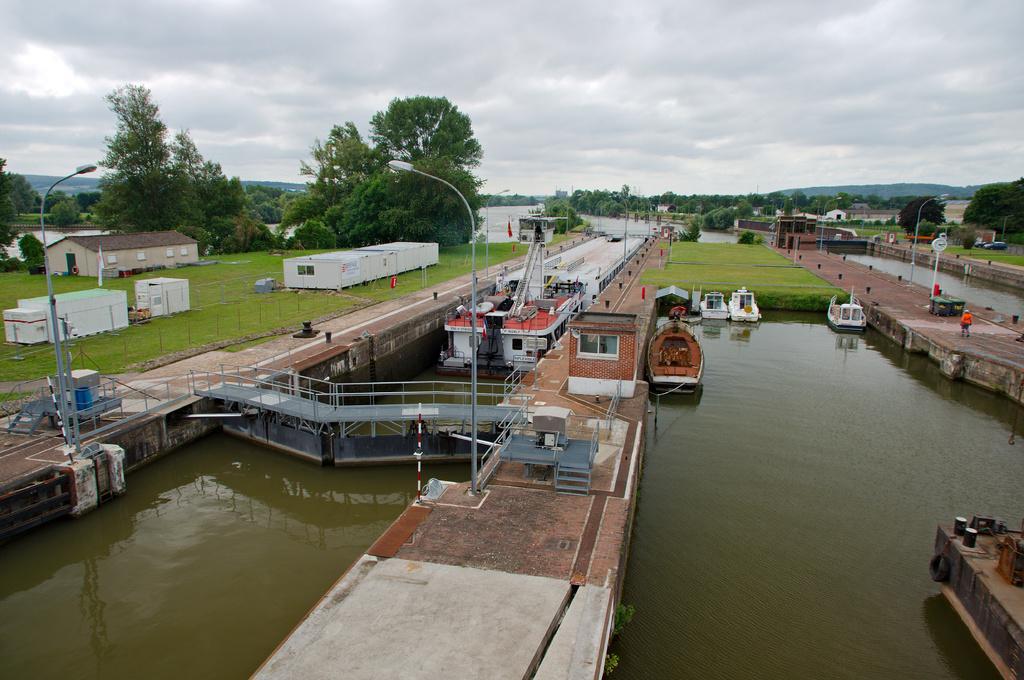Describe this image in one or two sentences. In this image In the middle there is a canal on which there are bridges and some boards visible, on the right side there are some poles, light poles, hill, trees, canals, persons, vehicles, at the top there is the sky. 